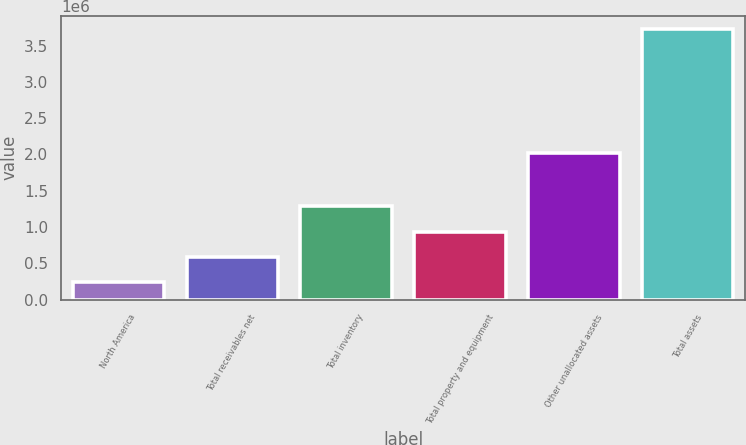Convert chart to OTSL. <chart><loc_0><loc_0><loc_500><loc_500><bar_chart><fcel>North America<fcel>Total receivables net<fcel>Total inventory<fcel>Total property and equipment<fcel>Other unallocated assets<fcel>Total assets<nl><fcel>241627<fcel>589810<fcel>1.28618e+06<fcel>937993<fcel>2.01647e+06<fcel>3.72346e+06<nl></chart> 